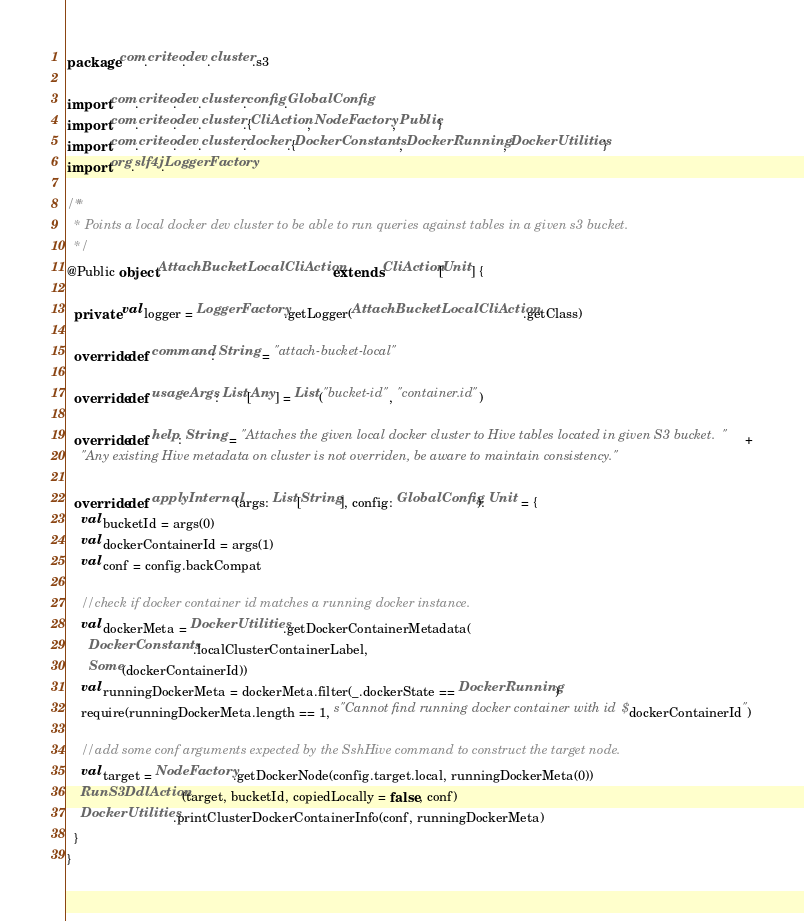<code> <loc_0><loc_0><loc_500><loc_500><_Scala_>package com.criteo.dev.cluster.s3

import com.criteo.dev.cluster.config.GlobalConfig
import com.criteo.dev.cluster.{CliAction, NodeFactory, Public}
import com.criteo.dev.cluster.docker.{DockerConstants, DockerRunning, DockerUtilities}
import org.slf4j.LoggerFactory

/**
  * Points a local docker dev cluster to be able to run queries against tables in a given s3 bucket.
  */
@Public object AttachBucketLocalCliAction extends CliAction[Unit] {

  private val logger = LoggerFactory.getLogger(AttachBucketLocalCliAction.getClass)

  override def command: String = "attach-bucket-local"

  override def usageArgs: List[Any] = List("bucket-id", "container.id")

  override def help: String = "Attaches the given local docker cluster to Hive tables located in given S3 bucket.  " +
    "Any existing Hive metadata on cluster is not overriden, be aware to maintain consistency."

  override def applyInternal(args: List[String], config: GlobalConfig): Unit = {
    val bucketId = args(0)
    val dockerContainerId = args(1)
    val conf = config.backCompat

    //check if docker container id matches a running docker instance.
    val dockerMeta = DockerUtilities.getDockerContainerMetadata(
      DockerConstants.localClusterContainerLabel,
      Some(dockerContainerId))
    val runningDockerMeta = dockerMeta.filter(_.dockerState == DockerRunning)
    require(runningDockerMeta.length == 1, s"Cannot find running docker container with id $dockerContainerId")

    //add some conf arguments expected by the SshHive command to construct the target node.
    val target = NodeFactory.getDockerNode(config.target.local, runningDockerMeta(0))
    RunS3DdlAction(target, bucketId, copiedLocally = false, conf)
    DockerUtilities.printClusterDockerContainerInfo(conf, runningDockerMeta)
  }
}
</code> 